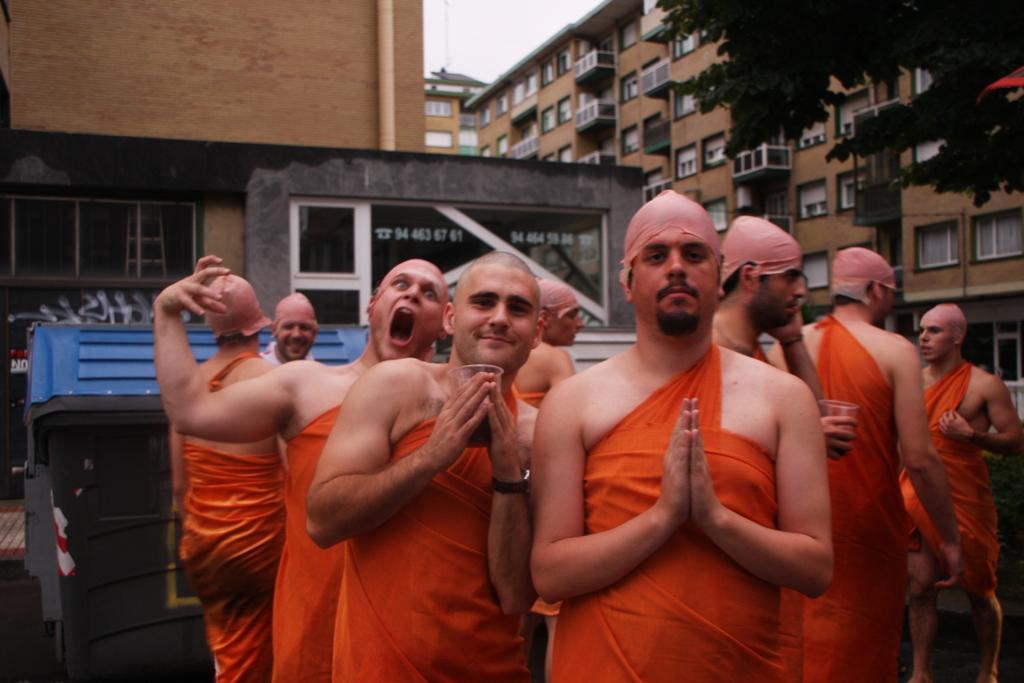Please provide a concise description of this image. In this picture we can see there are groups of people in the orange dress and behind the people there is a tree, buildings and a sky. 